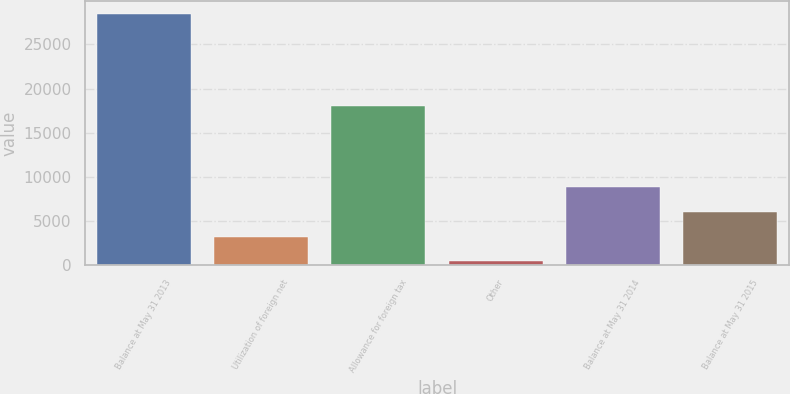Convert chart to OTSL. <chart><loc_0><loc_0><loc_500><loc_500><bar_chart><fcel>Balance at May 31 2013<fcel>Utilization of foreign net<fcel>Allowance for foreign tax<fcel>Other<fcel>Balance at May 31 2014<fcel>Balance at May 31 2015<nl><fcel>28464<fcel>3190.2<fcel>18061<fcel>382<fcel>8806.6<fcel>5998.4<nl></chart> 